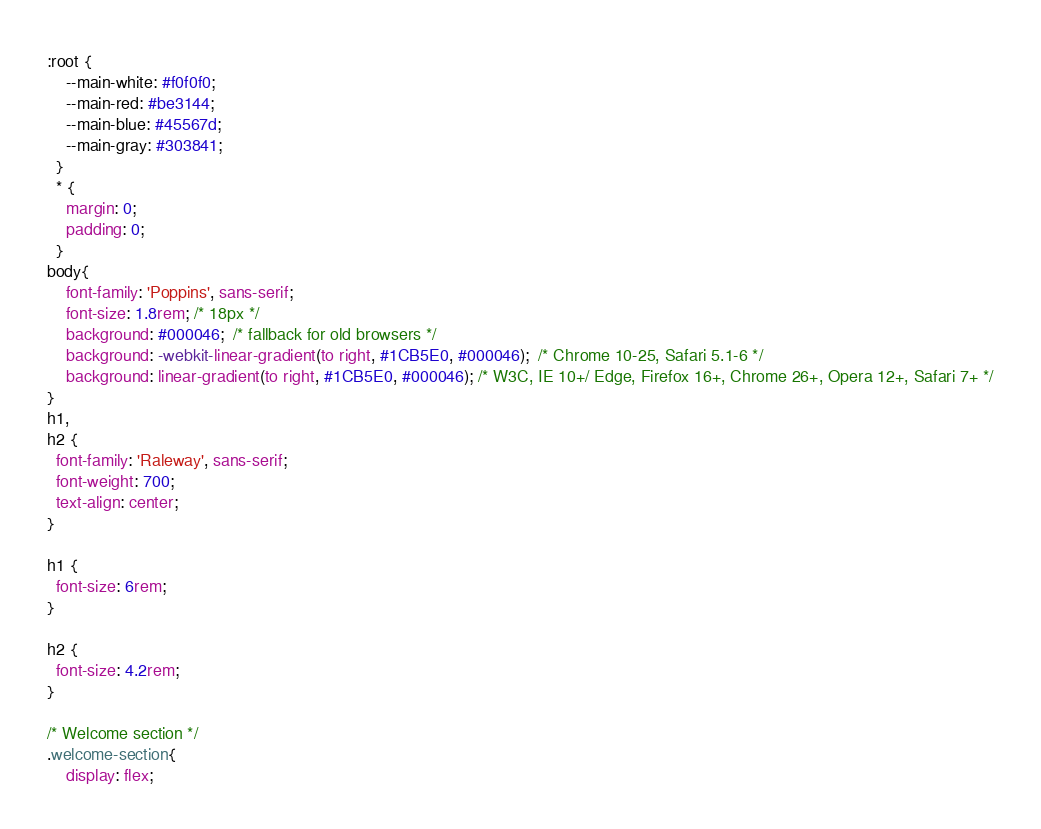<code> <loc_0><loc_0><loc_500><loc_500><_CSS_>:root {
    --main-white: #f0f0f0;
    --main-red: #be3144;
    --main-blue: #45567d;
    --main-gray: #303841;
  }
  * {
    margin: 0;
    padding: 0;
  }
body{
    font-family: 'Poppins', sans-serif;
    font-size: 1.8rem; /* 18px */
    background: #000046;  /* fallback for old browsers */
    background: -webkit-linear-gradient(to right, #1CB5E0, #000046);  /* Chrome 10-25, Safari 5.1-6 */
    background: linear-gradient(to right, #1CB5E0, #000046); /* W3C, IE 10+/ Edge, Firefox 16+, Chrome 26+, Opera 12+, Safari 7+ */
}
h1,
h2 {
  font-family: 'Raleway', sans-serif;
  font-weight: 700;
  text-align: center;
}

h1 {
  font-size: 6rem;
}

h2 {
  font-size: 4.2rem;
}

/* Welcome section */
.welcome-section{
    display: flex;</code> 